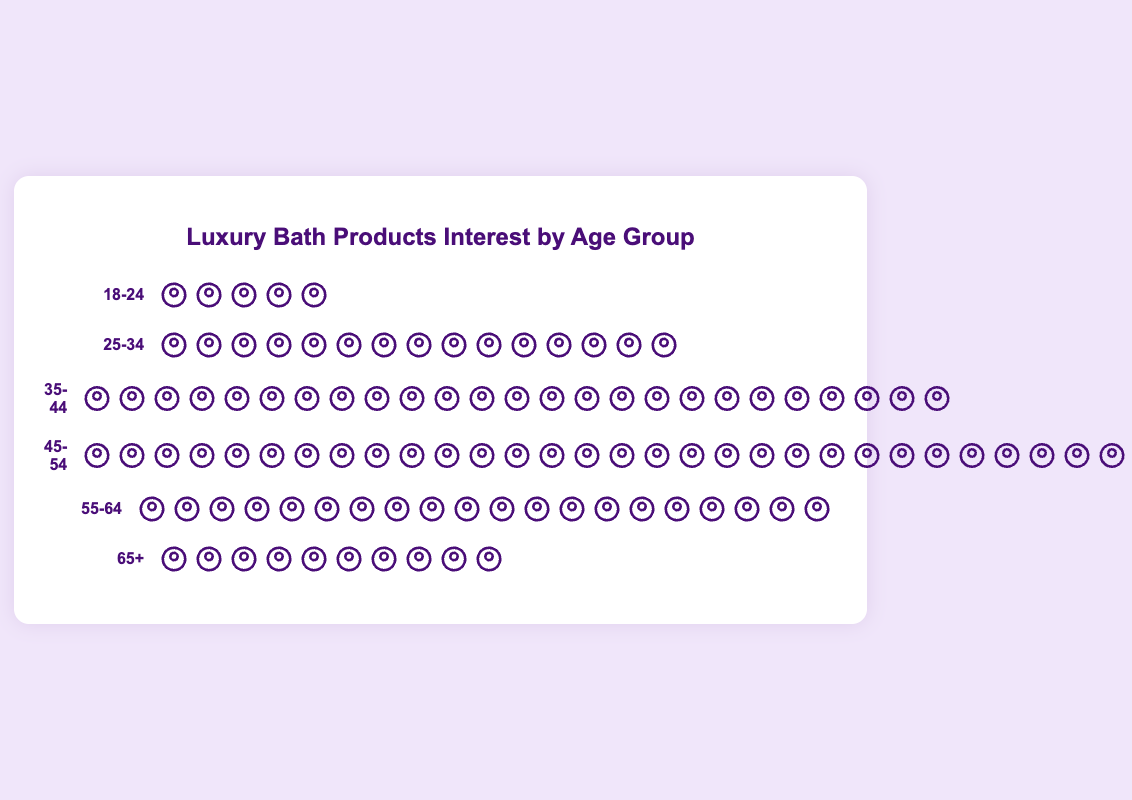What age group has the highest count of spa-goers interested in luxury bath products? The group "45-54" has the highest count. This can be seen by the number of icons, which is 30, the largest among all groups.
Answer: 45-54 Which two age groups combined have the same number of spa-goers as the 45-54 age group? The counts for "18-24" and "35-44" are 5 and 25 respectively. Their combined count is 5 + 25, which is 30, the same as the count for "45-54".
Answer: 18-24 and 35-44 What is the average count of spa-goers interested in luxury bath products for all age groups? Adding up all counts (5 + 15 + 25 + 30 + 20 + 10 = 105) and dividing by the number of age groups (6): 105 / 6 = 17.5
Answer: 17.5 How many more spa-goers are there in the "25-34" age group compared to the "18-24" age group? The count for "25-34" is 15 and for "18-24" is 5. The difference is 15 - 5 = 10.
Answer: 10 Which age group shows the least interest in luxury bath products? The "18-24" age group has the least count, with only 5 icons.
Answer: 18-24 By how much does the number of spa-goers in the "55-64" age group exceed the number in the "65+" age group? The count for "55-64" is 20 and for "65+" is 10. The difference is 20 - 10 = 10.
Answer: 10 What is the total count of spa-goers interested in luxury bath products from the age groups 35-44 and 55-64? The counts are 25 for "35-44" and 20 for "55-64". The total is 25 + 20 = 45.
Answer: 45 How many more spa-goers are there in the "45-54" age group compared to the "55-64" age group? The count for "45-54" is 30 and for "55-64" is 20. The difference is 30 - 20 = 10.
Answer: 10 What percentage of the total spa-goers interested in luxury bath products is in the "45-54" age group? The total count is 105. The count for "45-54" is 30. The percentage is (30 / 105) * 100 ≈ 28.57%.
Answer: 28.57% Which age group has double the count of spa-goers compared to the "65+" age group? The count for "65+" is 10. The "55-64" age group has a count of 20, which is double the count of 10.
Answer: 55-64 